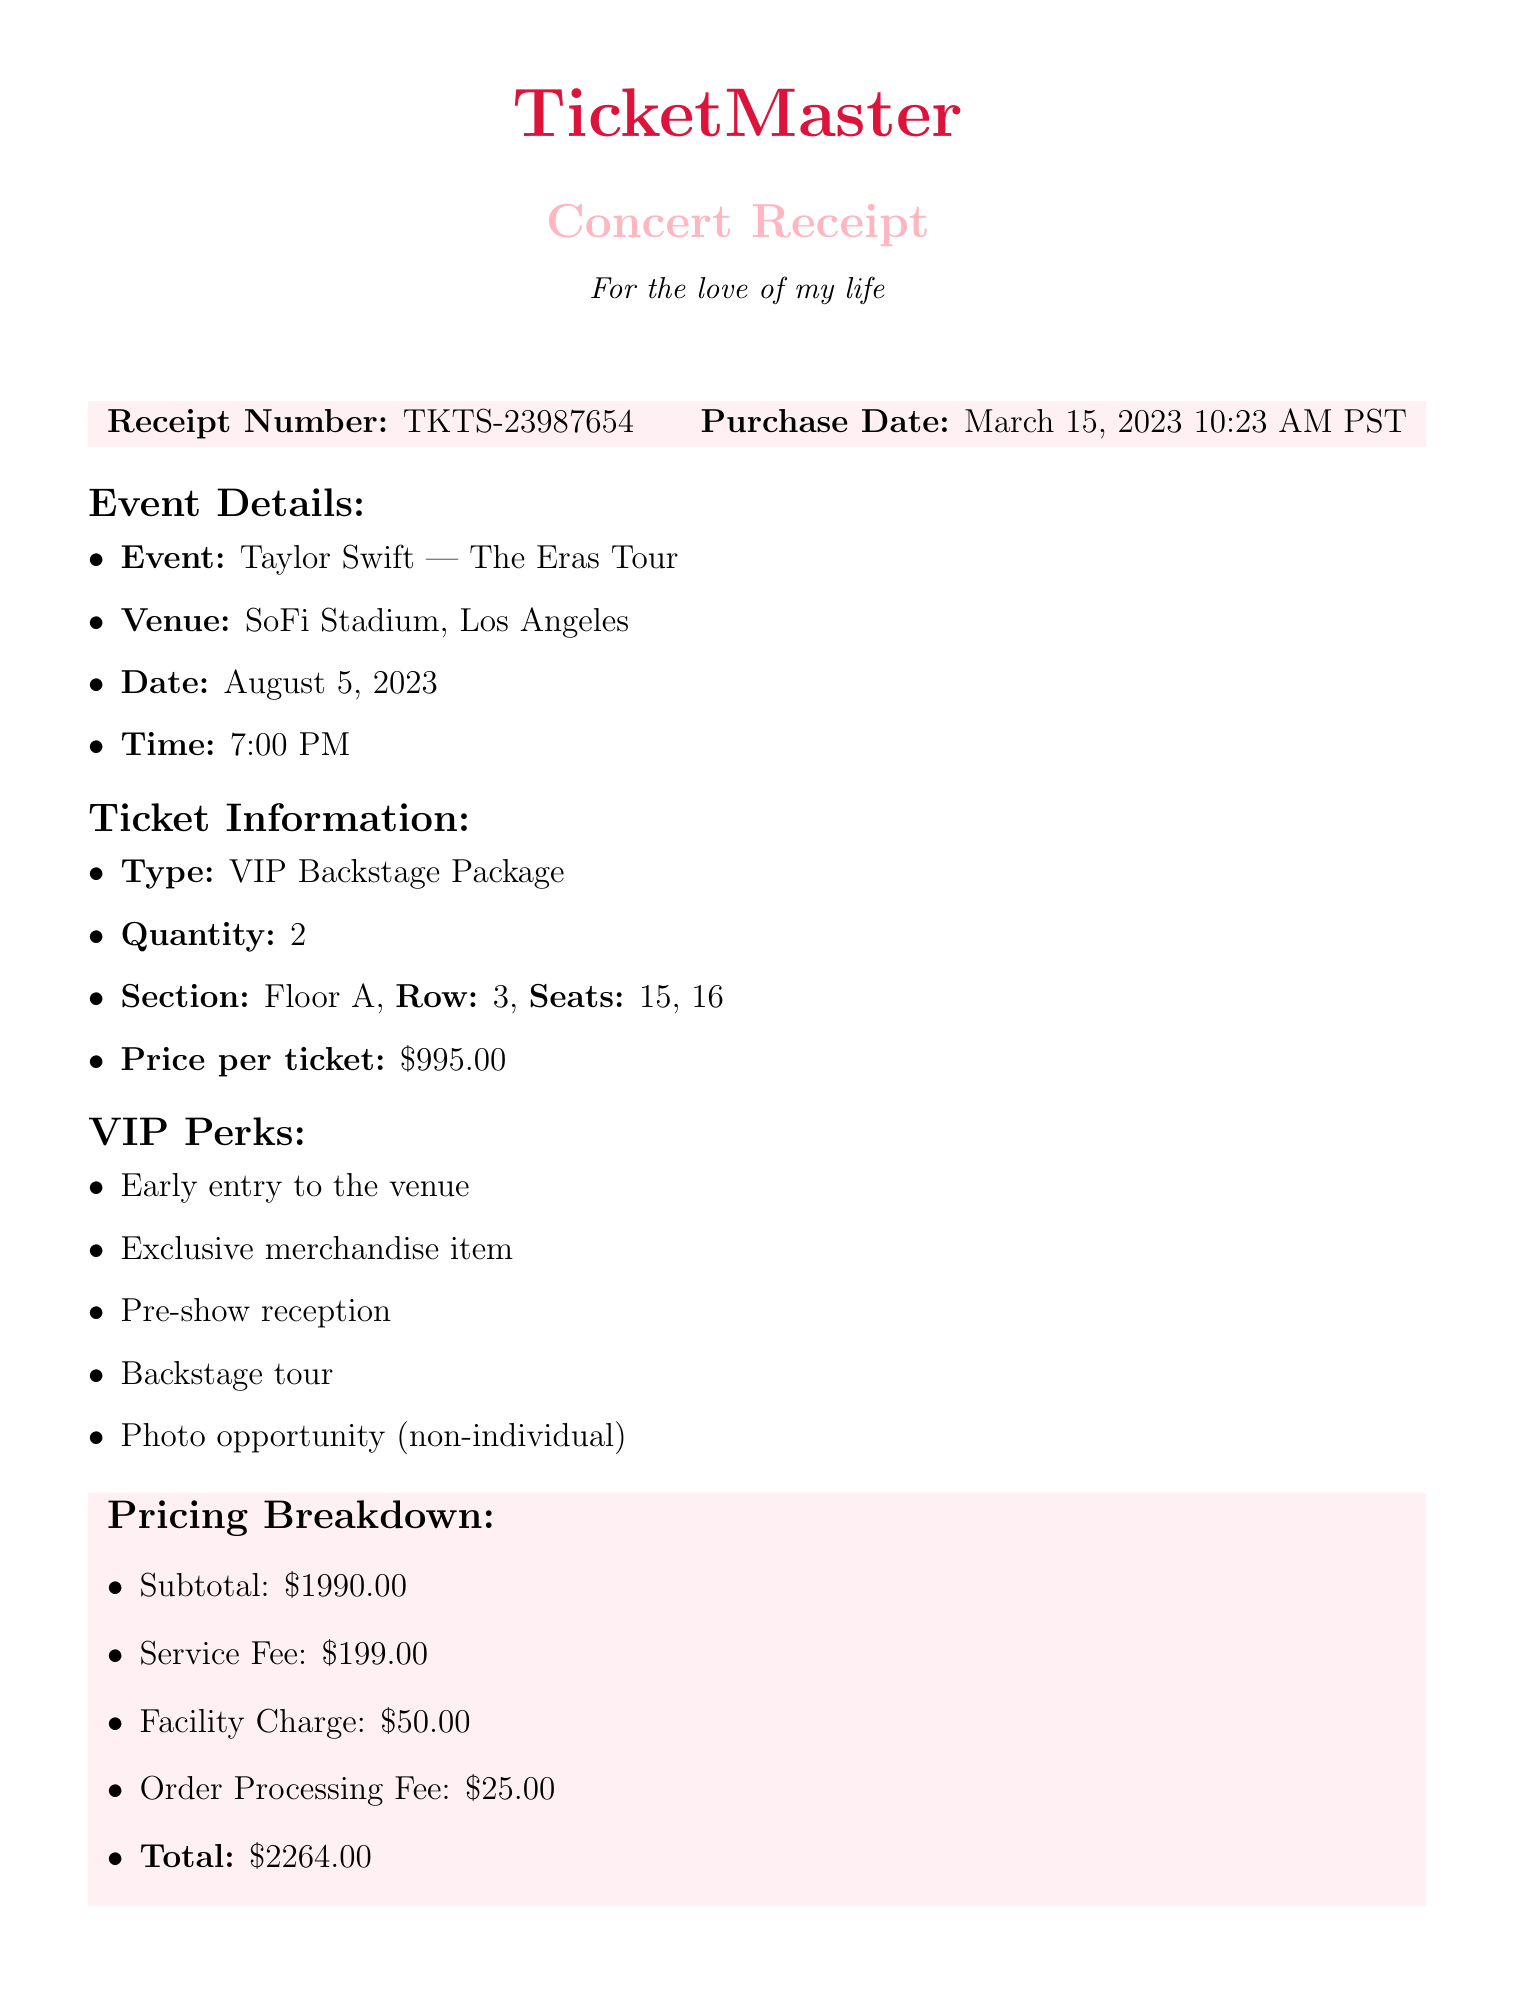What is the total amount spent on the tickets? The total amount is provided at the end of the receipt.
Answer: $2264.00 What is the receipt number? The receipt number is displayed prominently at the beginning.
Answer: TKTS-23987654 How many tickets were purchased? The quantity of tickets is indicated under the ticket information section.
Answer: 2 What special instructions were provided? The special instructions are listed towards the end of the document.
Answer: Please arrive at least 2 hours before the show for VIP check-in What perks are included in the VIP package? The VIP perks are listed in a specific section of the document.
Answer: Early entry to the venue, Exclusive merchandise item, Pre-show reception, Backstage tour, Photo opportunity (non-individual) What is the venue for the concert? The venue is specified in the event details section of the document.
Answer: SoFi Stadium, Los Angeles When was the purchase made? The purchase date is mentioned alongside the receipt number at the start.
Answer: March 15, 2023 10:23 AM PST 